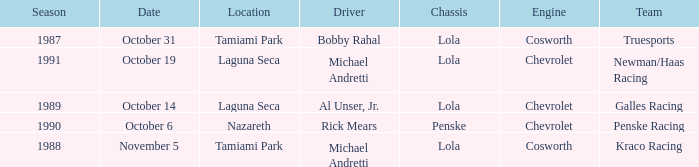On what date was the race at Nazareth? October 6. 